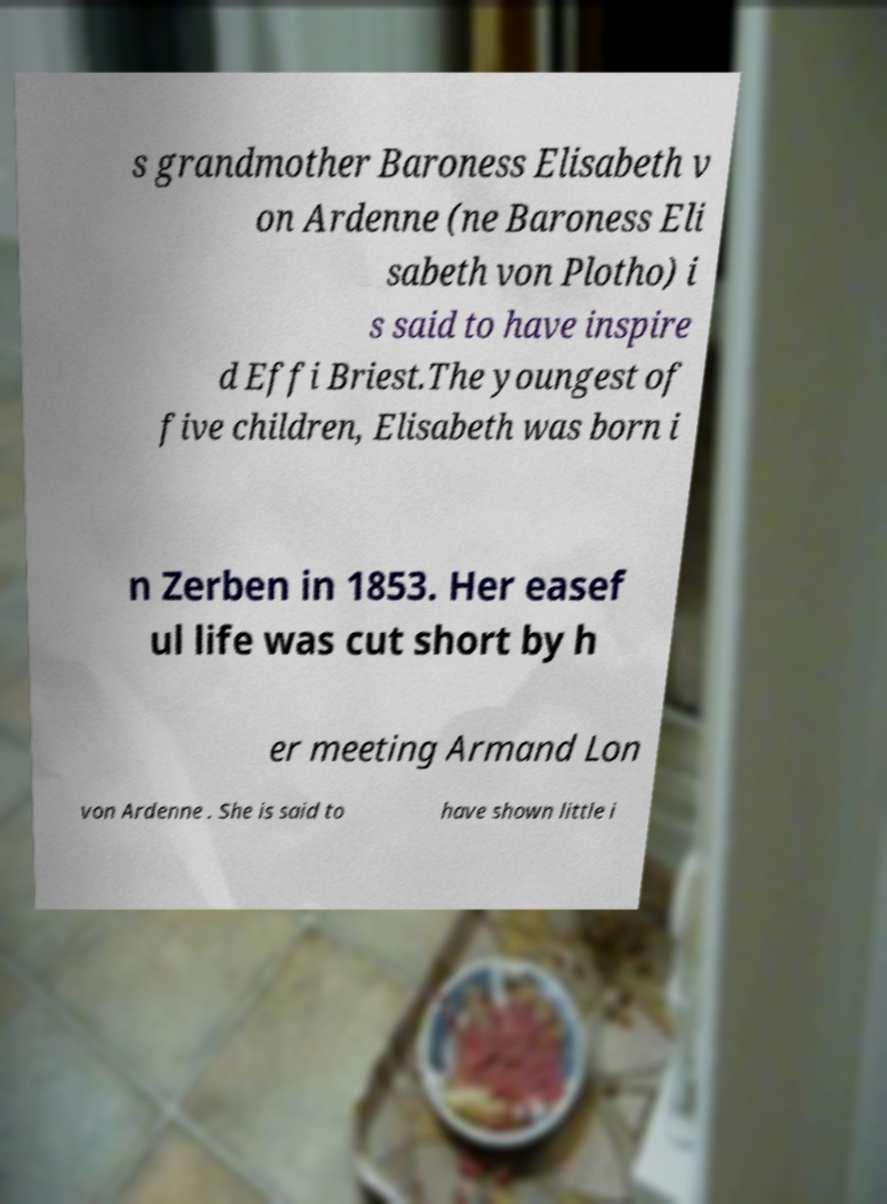For documentation purposes, I need the text within this image transcribed. Could you provide that? s grandmother Baroness Elisabeth v on Ardenne (ne Baroness Eli sabeth von Plotho) i s said to have inspire d Effi Briest.The youngest of five children, Elisabeth was born i n Zerben in 1853. Her easef ul life was cut short by h er meeting Armand Lon von Ardenne . She is said to have shown little i 